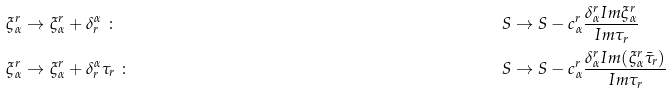<formula> <loc_0><loc_0><loc_500><loc_500>\xi ^ { r } _ { \alpha } & \to \xi ^ { r } _ { \alpha } + \delta _ { r } ^ { \alpha } \ \colon & S & \to S - c ^ { r } _ { \alpha } \frac { \delta _ { \alpha } ^ { r } I m \xi ^ { r } _ { \alpha } } { I m \tau _ { r } } \\ \xi ^ { r } _ { \alpha } & \to \xi ^ { r } _ { \alpha } + \delta _ { r } ^ { \alpha } \tau _ { r } \ \colon & S & \to S - c ^ { r } _ { \alpha } \frac { \delta _ { \alpha } ^ { r } I m ( \xi ^ { r } _ { \alpha } \bar { \tau } _ { r } ) } { I m \tau _ { r } }</formula> 